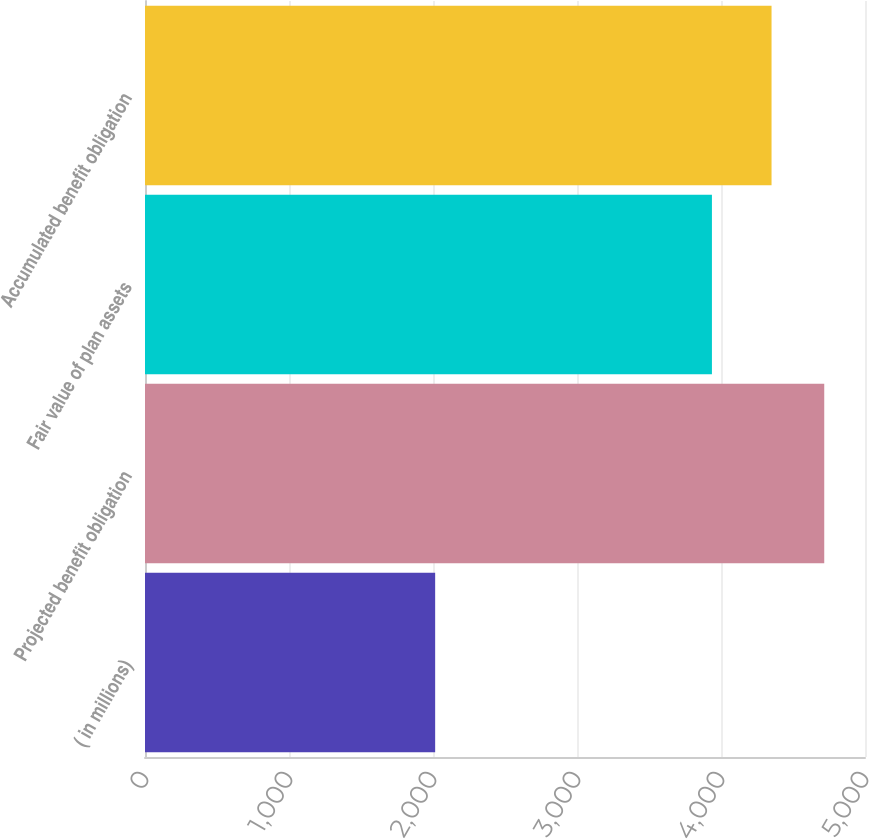Convert chart. <chart><loc_0><loc_0><loc_500><loc_500><bar_chart><fcel>( in millions)<fcel>Projected benefit obligation<fcel>Fair value of plan assets<fcel>Accumulated benefit obligation<nl><fcel>2015<fcel>4717<fcel>3937<fcel>4351<nl></chart> 